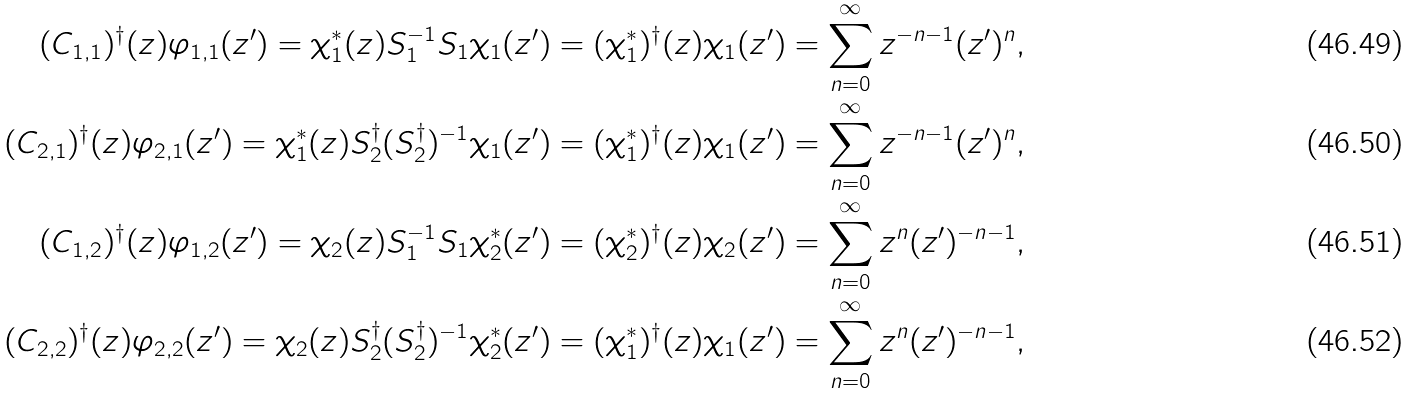<formula> <loc_0><loc_0><loc_500><loc_500>( C _ { 1 , 1 } ) ^ { \dagger } ( z ) \varphi _ { 1 , 1 } ( z ^ { \prime } ) = \chi _ { 1 } ^ { * } ( z ) S _ { 1 } ^ { - 1 } S _ { 1 } \chi _ { 1 } ( z ^ { \prime } ) = ( \chi _ { 1 } ^ { * } ) ^ { \dagger } ( z ) \chi _ { 1 } ( z ^ { \prime } ) & = \sum _ { n = 0 } ^ { \infty } z ^ { - n - 1 } ( z ^ { \prime } ) ^ { n } , \\ ( C _ { 2 , 1 } ) ^ { \dagger } ( z ) \varphi _ { 2 , 1 } ( z ^ { \prime } ) = \chi _ { 1 } ^ { * } ( z ) S _ { 2 } ^ { \dagger } ( S _ { 2 } ^ { \dagger } ) ^ { - 1 } \chi _ { 1 } ( z ^ { \prime } ) = ( \chi _ { 1 } ^ { * } ) ^ { \dagger } ( z ) \chi _ { 1 } ( z ^ { \prime } ) & = \sum _ { n = 0 } ^ { \infty } z ^ { - n - 1 } ( z ^ { \prime } ) ^ { n } , \\ ( C _ { 1 , 2 } ) ^ { \dagger } ( z ) \varphi _ { 1 , 2 } ( z ^ { \prime } ) = \chi _ { 2 } ( z ) S _ { 1 } ^ { - 1 } S _ { 1 } \chi _ { 2 } ^ { * } ( z ^ { \prime } ) = ( \chi _ { 2 } ^ { * } ) ^ { \dagger } ( z ) \chi _ { 2 } ( z ^ { \prime } ) & = \sum _ { n = 0 } ^ { \infty } z ^ { n } ( z ^ { \prime } ) ^ { - n - 1 } , \\ ( C _ { 2 , 2 } ) ^ { \dagger } ( z ) \varphi _ { 2 , 2 } ( z ^ { \prime } ) = \chi _ { 2 } ( z ) S _ { 2 } ^ { \dagger } ( S _ { 2 } ^ { \dagger } ) ^ { - 1 } \chi ^ { * } _ { 2 } ( z ^ { \prime } ) = ( \chi _ { 1 } ^ { * } ) ^ { \dagger } ( z ) \chi _ { 1 } ( z ^ { \prime } ) & = \sum _ { n = 0 } ^ { \infty } z ^ { n } ( z ^ { \prime } ) ^ { - n - 1 } ,</formula> 